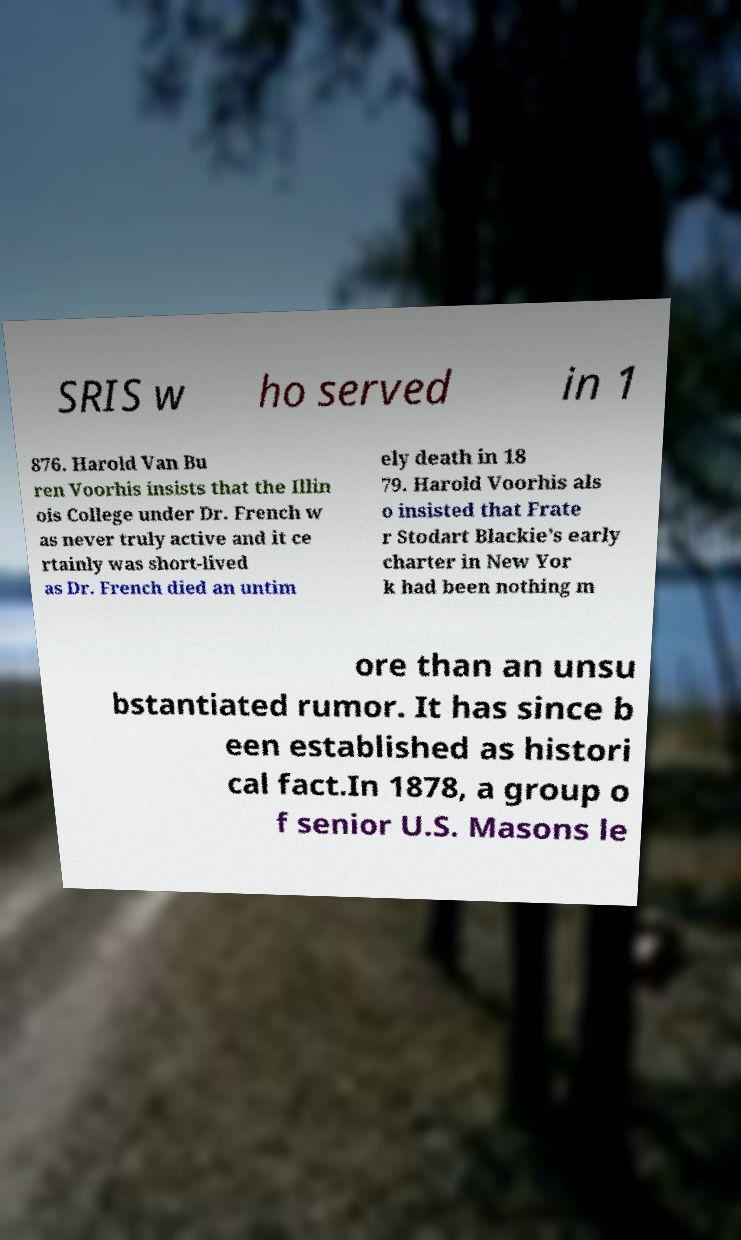For documentation purposes, I need the text within this image transcribed. Could you provide that? SRIS w ho served in 1 876. Harold Van Bu ren Voorhis insists that the Illin ois College under Dr. French w as never truly active and it ce rtainly was short-lived as Dr. French died an untim ely death in 18 79. Harold Voorhis als o insisted that Frate r Stodart Blackie's early charter in New Yor k had been nothing m ore than an unsu bstantiated rumor. It has since b een established as histori cal fact.In 1878, a group o f senior U.S. Masons le 